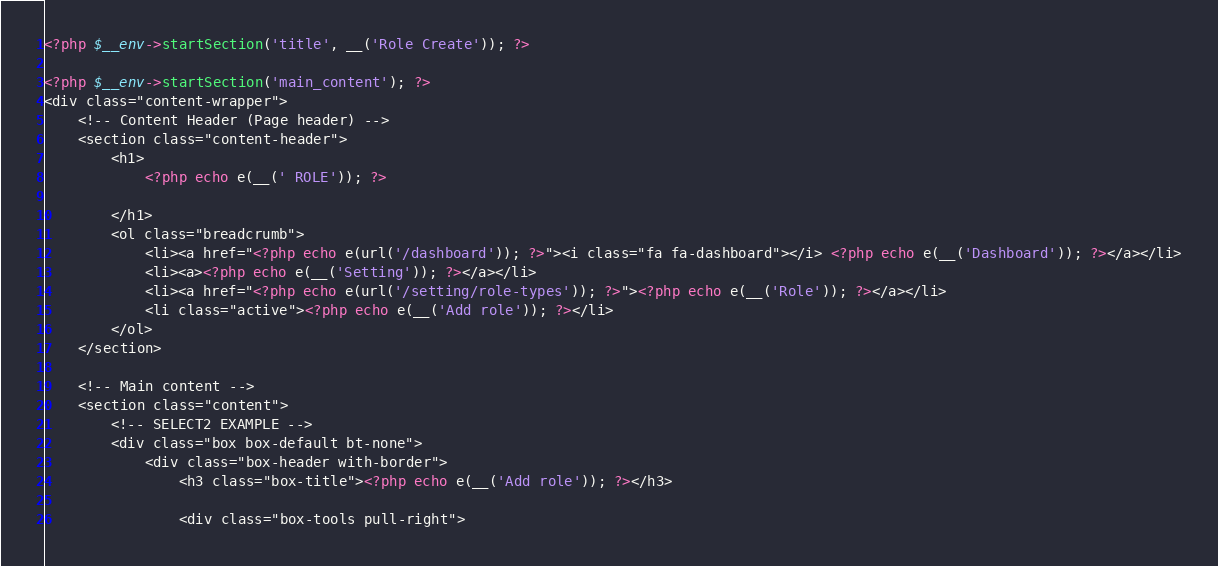Convert code to text. <code><loc_0><loc_0><loc_500><loc_500><_PHP_><?php $__env->startSection('title', __('Role Create')); ?>

<?php $__env->startSection('main_content'); ?>
<div class="content-wrapper">
    <!-- Content Header (Page header) -->
    <section class="content-header">
        <h1>
            <?php echo e(__(' ROLE')); ?>

        </h1>
        <ol class="breadcrumb">
            <li><a href="<?php echo e(url('/dashboard')); ?>"><i class="fa fa-dashboard"></i> <?php echo e(__('Dashboard')); ?></a></li>
            <li><a><?php echo e(__('Setting')); ?></a></li>
            <li><a href="<?php echo e(url('/setting/role-types')); ?>"><?php echo e(__('Role')); ?></a></li>
            <li class="active"><?php echo e(__('Add role')); ?></li>
        </ol>
    </section>

    <!-- Main content -->
    <section class="content">
        <!-- SELECT2 EXAMPLE -->
        <div class="box box-default bt-none">
            <div class="box-header with-border">
                <h3 class="box-title"><?php echo e(__('Add role')); ?></h3>

                <div class="box-tools pull-right"></code> 